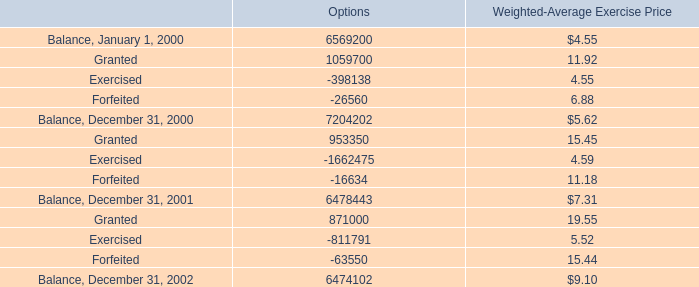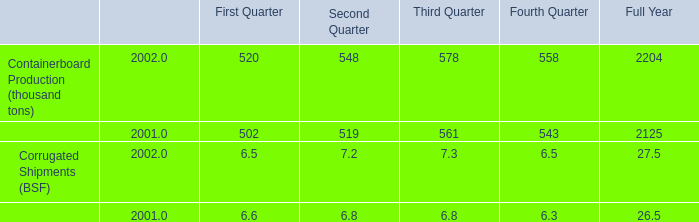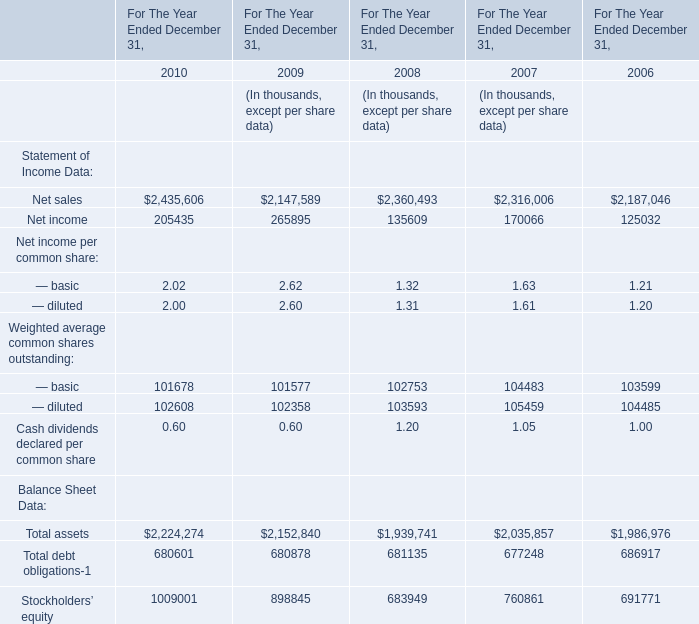what is the total value of the balance of options as of january 1 , 2000 , in millions? 
Computations: ((6569200 * 4.55) / 1000000)
Answer: 29.88986. 